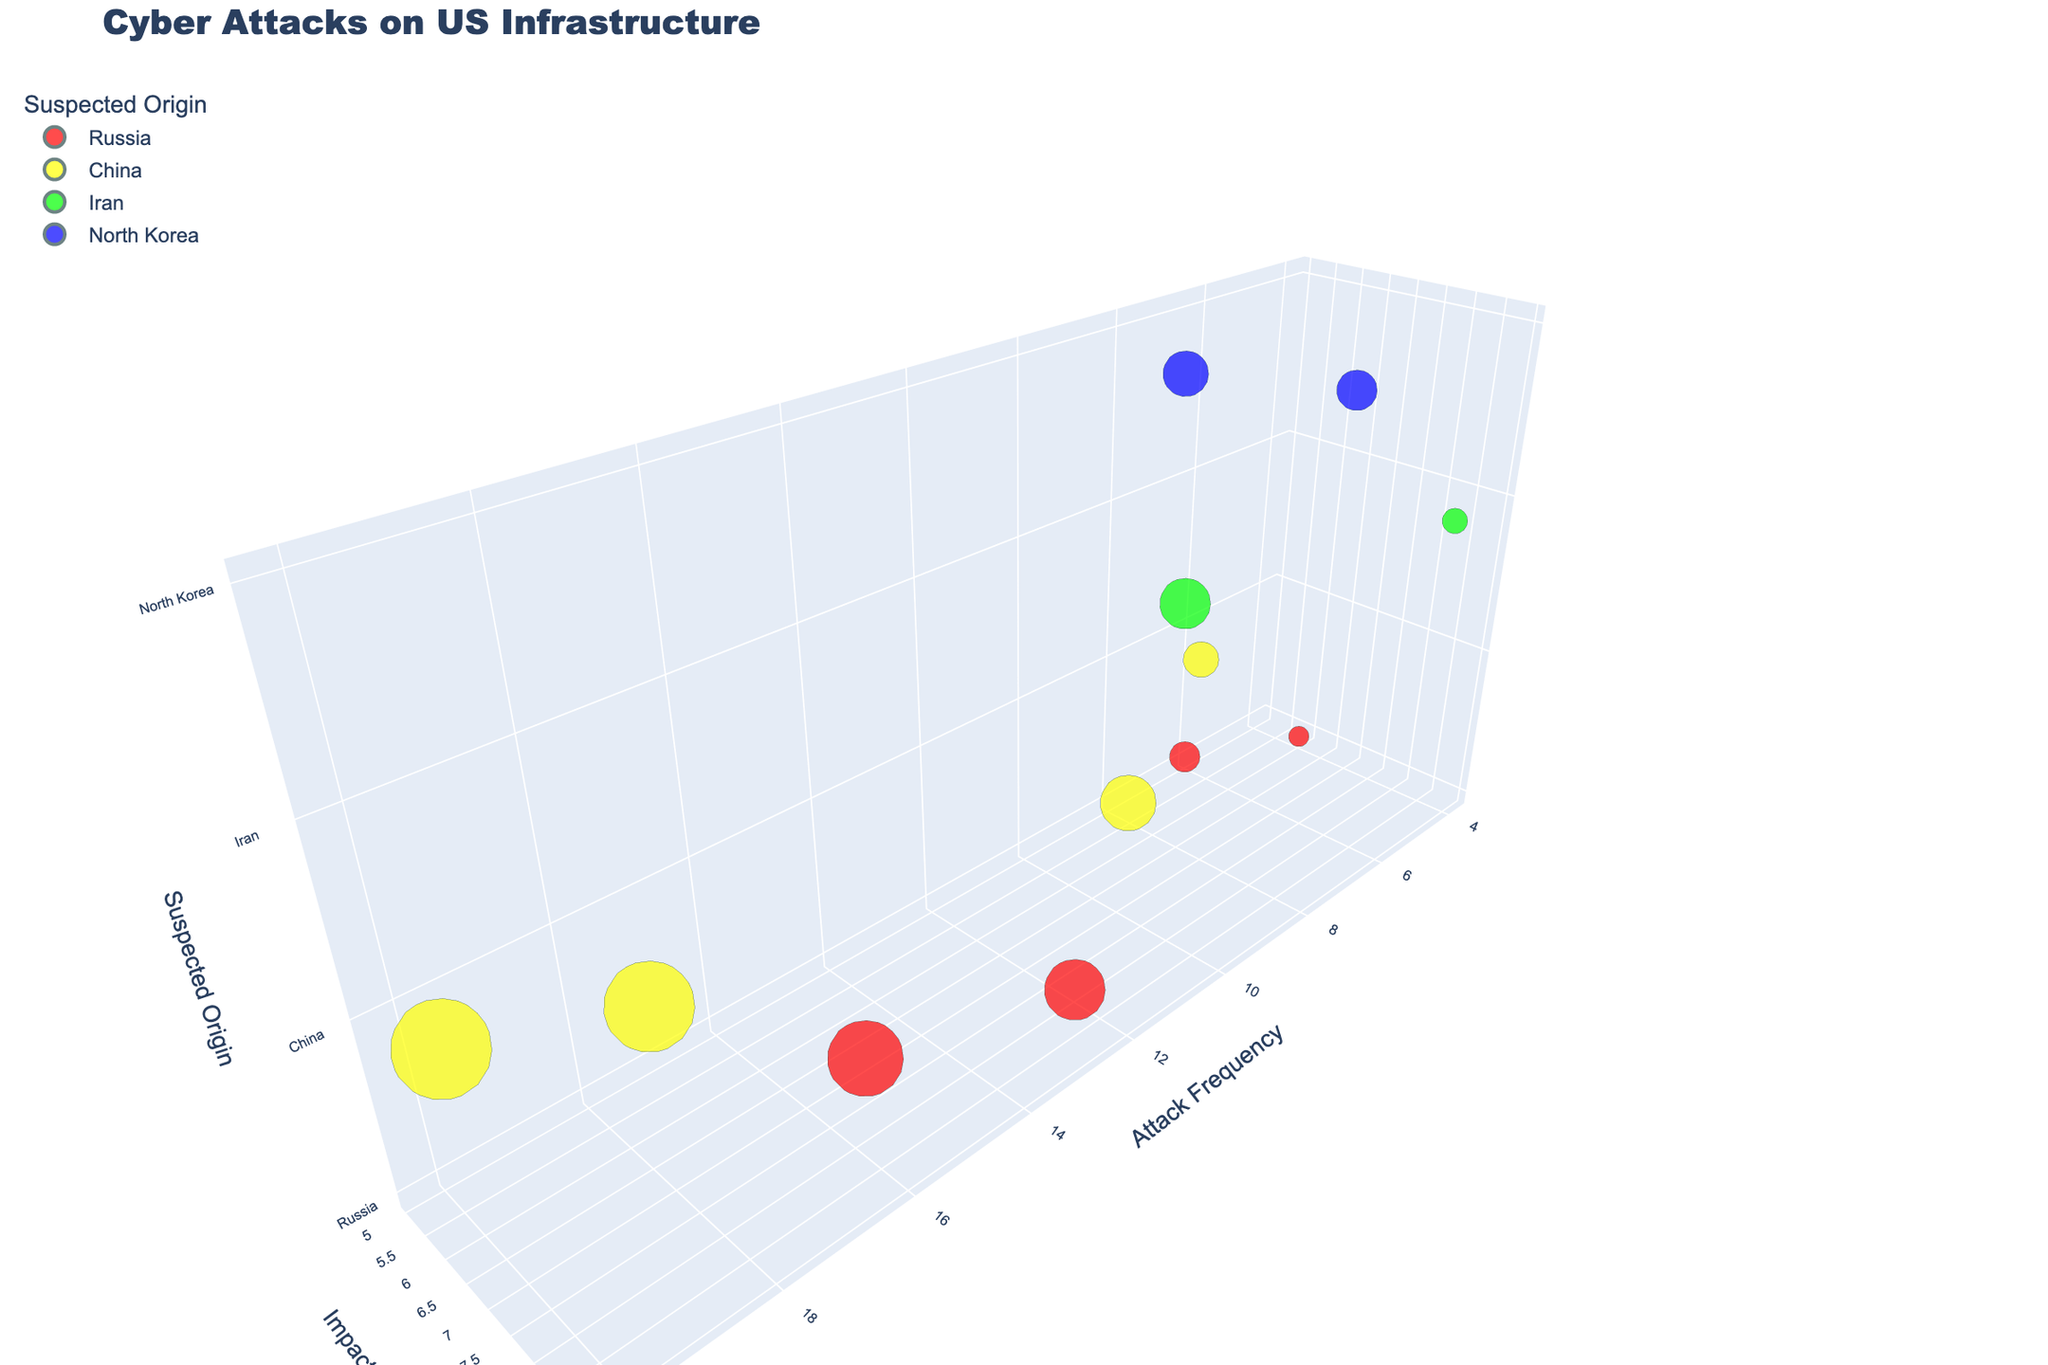What is the title of the chart? The title can be found at the top of the chart, it reads "Cyber Attacks on US Infrastructure."
Answer: Cyber Attacks on US Infrastructure Which country is associated with the frequency 20 and severity 6? By looking for the data point with a frequency of 20 and severity of 6 on the chart, you can see it is associated with China.
Answer: China How many attacks have a severity of 9? Counting the data points with a severity of 9 shows there are three such attacks, involving Iran and North Korea.
Answer: Three Compare the severities of attacks from Russia and China. Which country has higher severity on average? Calculate the average severity for attacks from Russia and China. For Russia: (8+7+5+6)/4 = 6.5. For China: (6+7+8)/3 ≈ 7. So China has a higher average severity.
Answer: China Which attack has the highest frequency, and what is its suspected origin? The data point with the highest frequency (20) labeled "Financial Institution Attack" indicates the suspected origin is China.
Answer: Financial Institution Attack, China What is the average severity of attacks from Iran? Calculate the average severity of the two attacks from Iran: (9+8)/2 = 8.5.
Answer: 8.5 What is the relationship between attack frequency and severity for Electoral System Interference? For the Electoral System Interference attack (15,7), observe that a high frequency does not necessarily correlate with a proportionately high severity value.
Answer: High frequency, moderate severity Which country is associated with the most diverse range of infrastructural attacks? Counting the unique types of attacks per country, China (Water Treatment, Financial Institutions, Healthcare Data, Industrial Control Systems) accounts for the most diverse range (4 types).
Answer: China 